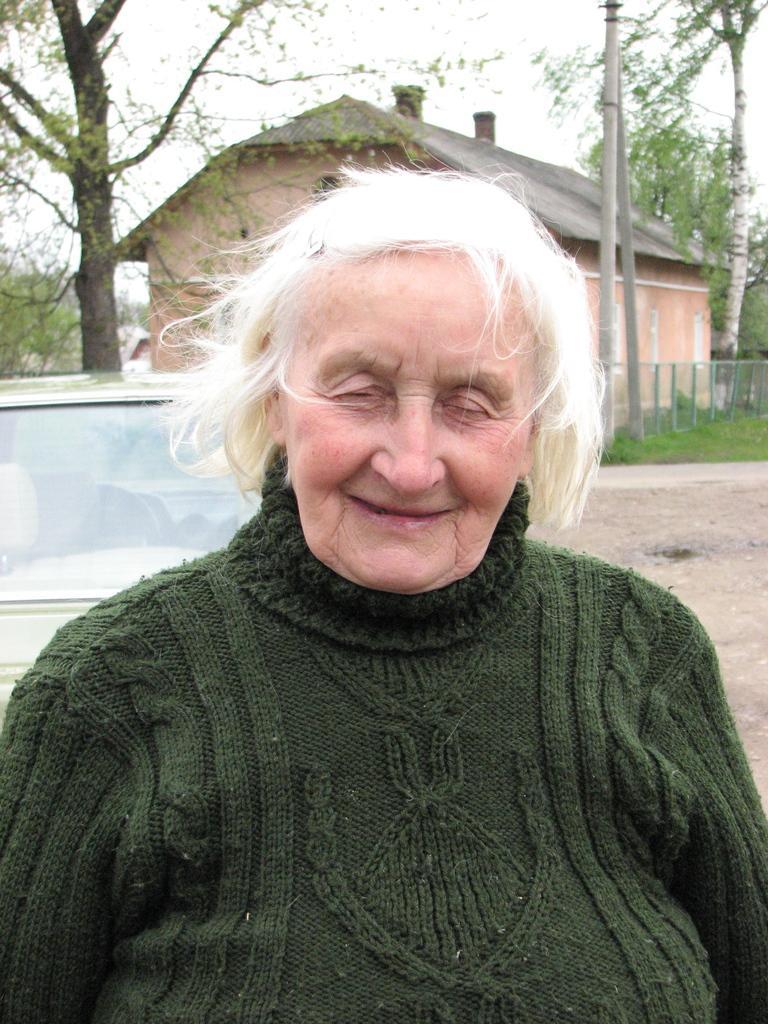How would you summarize this image in a sentence or two? In the center of the image we can see a lady is wearing a sweater. In the background of the image we can see the trees, fence, grass, poles, house, roof, car and ground. At the top of the image we can see the sky. 